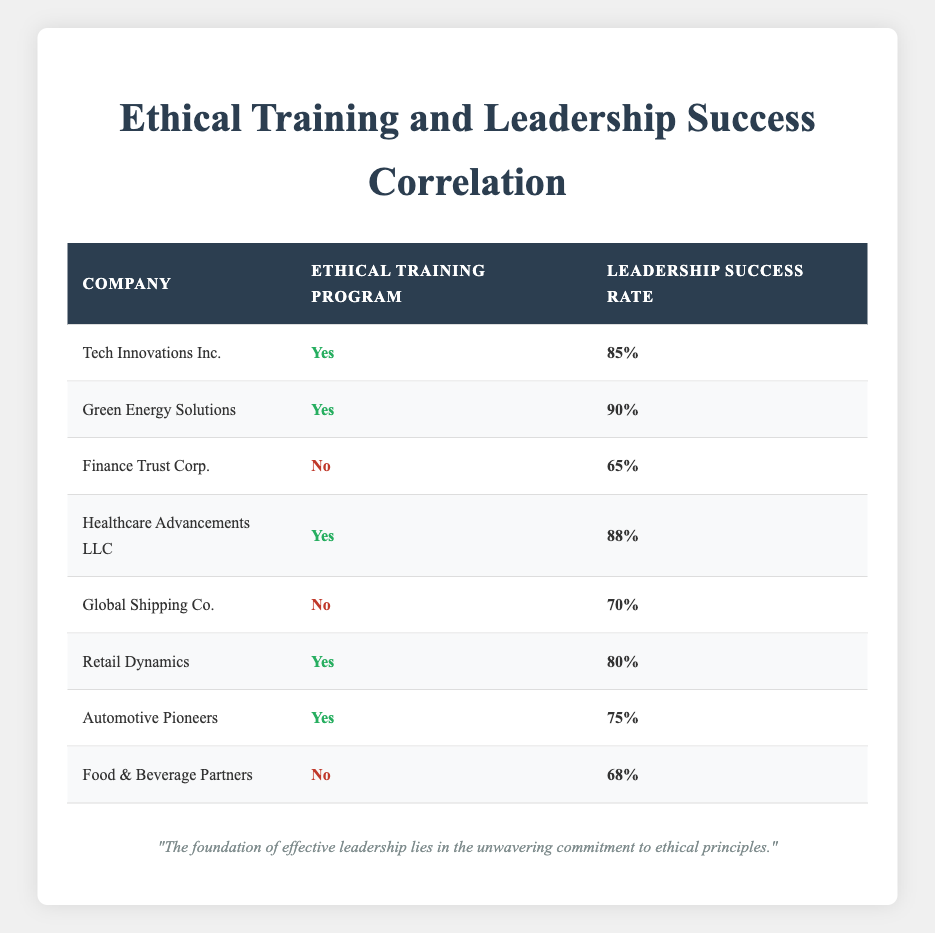What is the leadership success rate of Healthcare Advancements LLC? The leadership success rate for Healthcare Advancements LLC is directly provided in the table, listed as 88%.
Answer: 88% How many companies have an ethical training program? By counting the rows with "Yes" under the Ethical Training Program column, we find there are 5 companies (Tech Innovations Inc., Green Energy Solutions, Healthcare Advancements LLC, Retail Dynamics, and Automotive Pioneers).
Answer: 5 What is the leadership success rate for companies without an ethical training program? The success rates for companies without a program are 65% (Finance Trust Corp.), 70% (Global Shipping Co.), and 68% (Food & Beverage Partners). The average of these three values is (65 + 70 + 68) / 3 = 67.67%.
Answer: 67.67% Is there a company with an ethical training program that has a leadership success rate lower than 80%? Looking at the companies with a training program, Automotive Pioneers has a success rate of 75%, which is lower than 80%. Thus, the answer is yes.
Answer: Yes Which company has the highest leadership success rate and does it have an ethical training program? Green Energy Solutions has the highest leadership success rate of 90% and it does have an ethical training program. Thus, this company meets both criteria.
Answer: Green Energy Solutions, Yes What is the difference in leadership success rates between companies with and without an ethical training program? The average success rate for companies with training is (85 + 90 + 88 + 80 + 75) / 5 = 83.6%, and for those without it's (65 + 70 + 68) / 3 = 67.67%. The difference is 83.6% - 67.67% = 15.93%.
Answer: 15.93% How many companies exhibit a leadership success rate above 80%? The companies with success rates above 80% are Tech Innovations Inc. (85%), Green Energy Solutions (90%), and Healthcare Advancements LLC (88%). Thus, there are 3 companies.
Answer: 3 Does the leadership success rate increase with the presence of an ethical training program? The average leadership success rate for companies with ethical training is 83.6%, while for those without is 67.67%, showing an increase of 15.93% on average when an ethical program is present.
Answer: Yes 